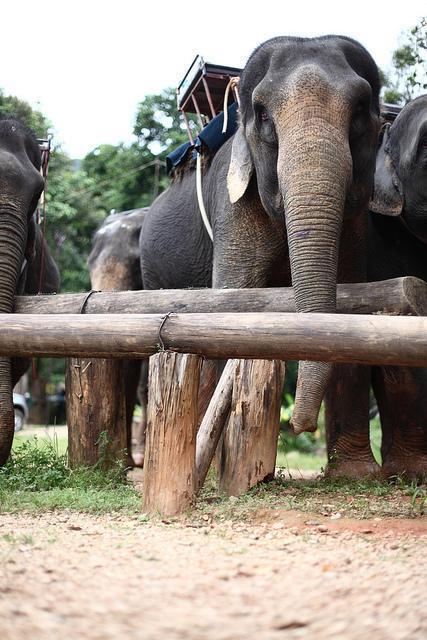How many elephants are there?
Give a very brief answer. 4. 